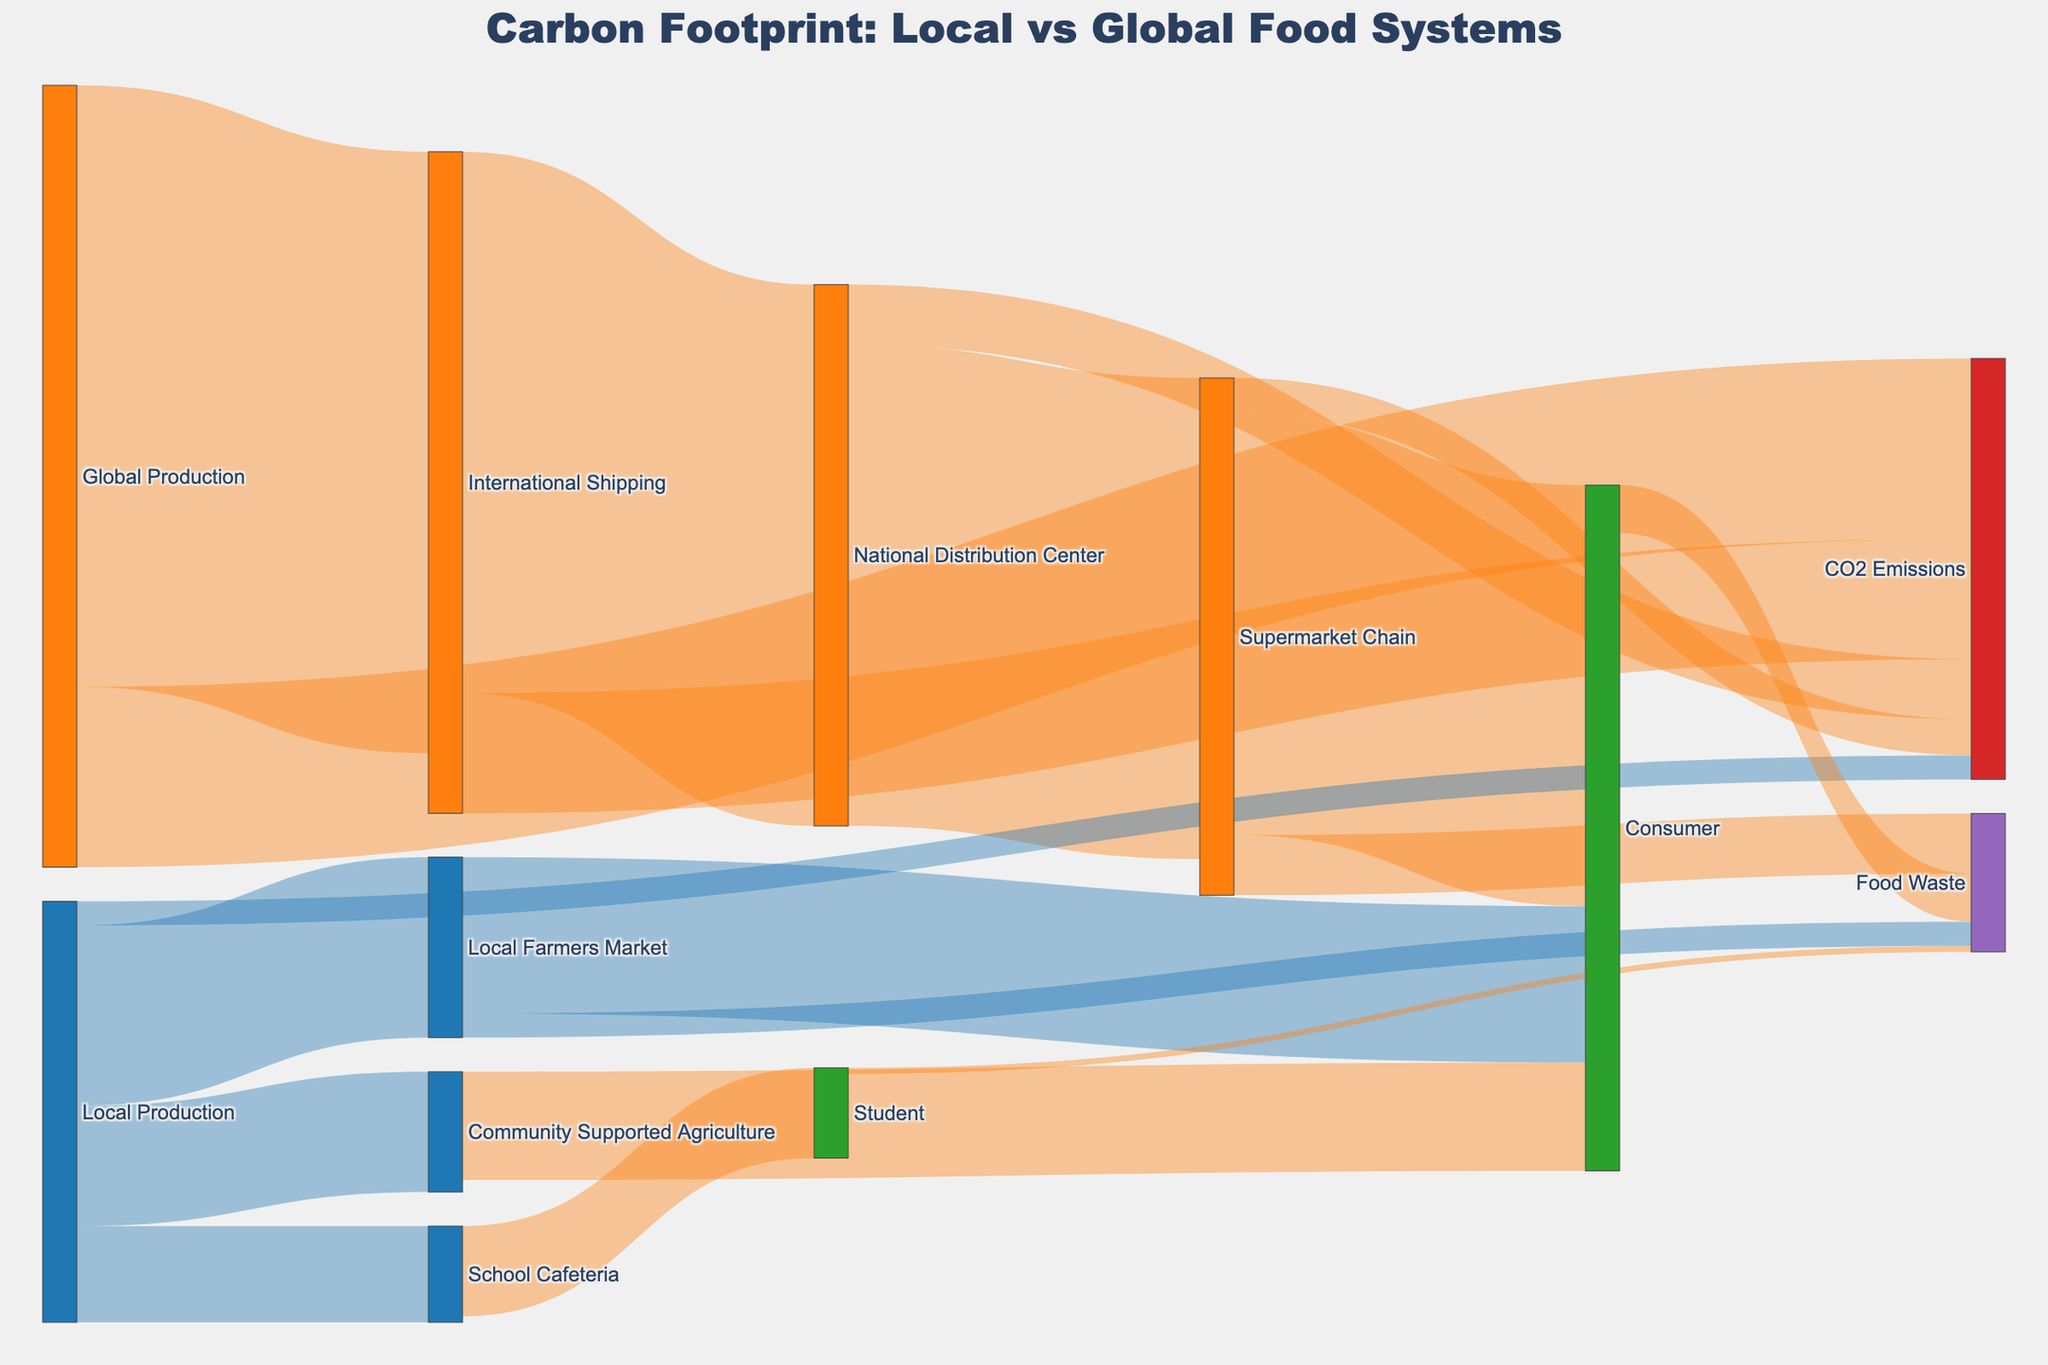What is the title of the figure? The title text is shown at the top of the figure in bold and larger font size.
Answer: Carbon Footprint: Local vs Global Food Systems How many pathways lead from Local Production to the Consumer through intermediary nodes? By examining the flow paths in the Sankey diagram, Local Production connects to three intermediary nodes: Local Farmers Market, Community Supported Agriculture, and School Cafeteria. Each of these then connects to Consumer or Student. Summarizing the connections: Local Production → Local Farmers Market → Consumer, Local Production → Community Supported Agriculture → Consumer, Local Production → School Cafeteria → Student.
Answer: Three pathways What is the total carbon dioxide (CO2) emissions from Global Production? Global Production has its own CO2 emissions and contributes indirectly through International Shipping and the National Distribution Center. By summing these, we get 150 (Global Production) + 100 (International Shipping) + 50 (National Distribution Center) + 30 (Supermarket Chain).
Answer: 330 tons of CO2 Compare the CO2 emissions between Local Production and Global Production alone. Which one is higher and by how much? Local Production accounts for 20 tons of CO2, while Global Production accounts for 150 tons of CO2 directly. The difference can be calculated by subtracting the lower value from the higher value: 150 - 20 = 130.
Answer: Global Production is higher by 130 tons of CO2 How does the Food Waste at the Supermarket Chain compare to that at the Local Farmers Market? According to the diagram, Food Waste from the Supermarket Chain is 50 tons, while from the Local Farmers Market it's 20 tons. To compare them, just subtract the smaller value from the larger one: 50 - 20 = 30.
Answer: Supermarket Chain has 30 tons more food waste How much food waste is generated by consumers and students combined? The food waste from Consumer is 40 tons, and from Student is 5 tons. Summing these values: 40 + 5 = 45.
Answer: 45 tons What is the combined value of food transported from Local Farmers Market and Community Supported Agriculture to Consumers? From the diagram, Local Farmers Market sends 130 tons to Consumers, and Community Supported Agriculture sends 90 tons. Summing these values gives 130 + 90 = 220.
Answer: 220 tons Based on the diagram, which food system has a higher direct carbon footprint, Local or Global, and by how much? The Local Production has a direct carbon footprint of 20 tons of CO2, whereas the Global Production has 150 tons of CO2. Subtracting the smaller value from the larger gives 150 - 20 = 130.
Answer: Global Production by 130 tons How many different distribution systems are involved in the Global Production chain before the end consumer? The path from Global Production to the end consumer involves these steps: International Shipping, National Distribution Center, Supermarket Chain, and then Consumer. This totals to four distinct distribution steps.
Answer: Four steps Which has more food waste: Consumers or the Supermarket Chain, and by what amount? The diagram shows Consumers generating 40 tons of food waste and the Supermarket Chain generating 50 tons. By subtracting the smaller number from the larger one, we get 50 - 40 = 10.
Answer: Supermarket Chain by 10 tons 